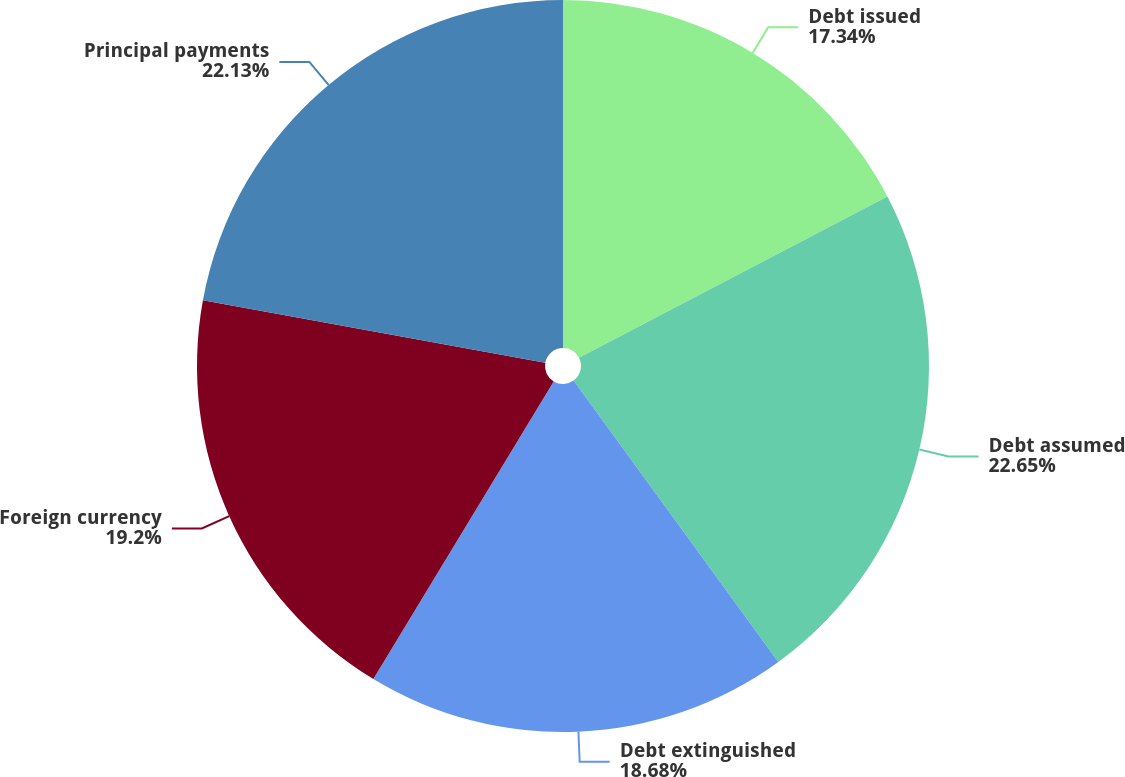Convert chart to OTSL. <chart><loc_0><loc_0><loc_500><loc_500><pie_chart><fcel>Debt issued<fcel>Debt assumed<fcel>Debt extinguished<fcel>Foreign currency<fcel>Principal payments<nl><fcel>17.34%<fcel>22.65%<fcel>18.68%<fcel>19.2%<fcel>22.13%<nl></chart> 